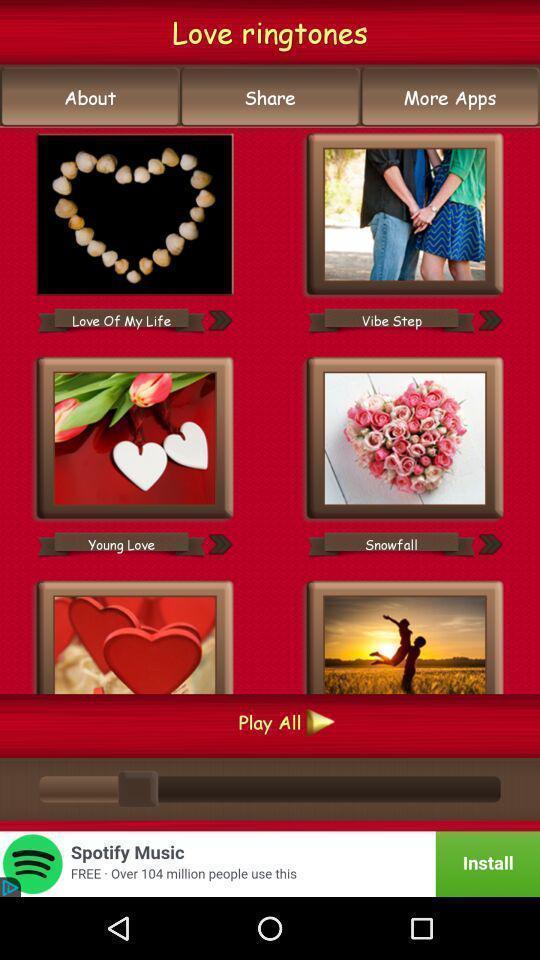Tell me what you see in this picture. Page showing various ring tones on app. 